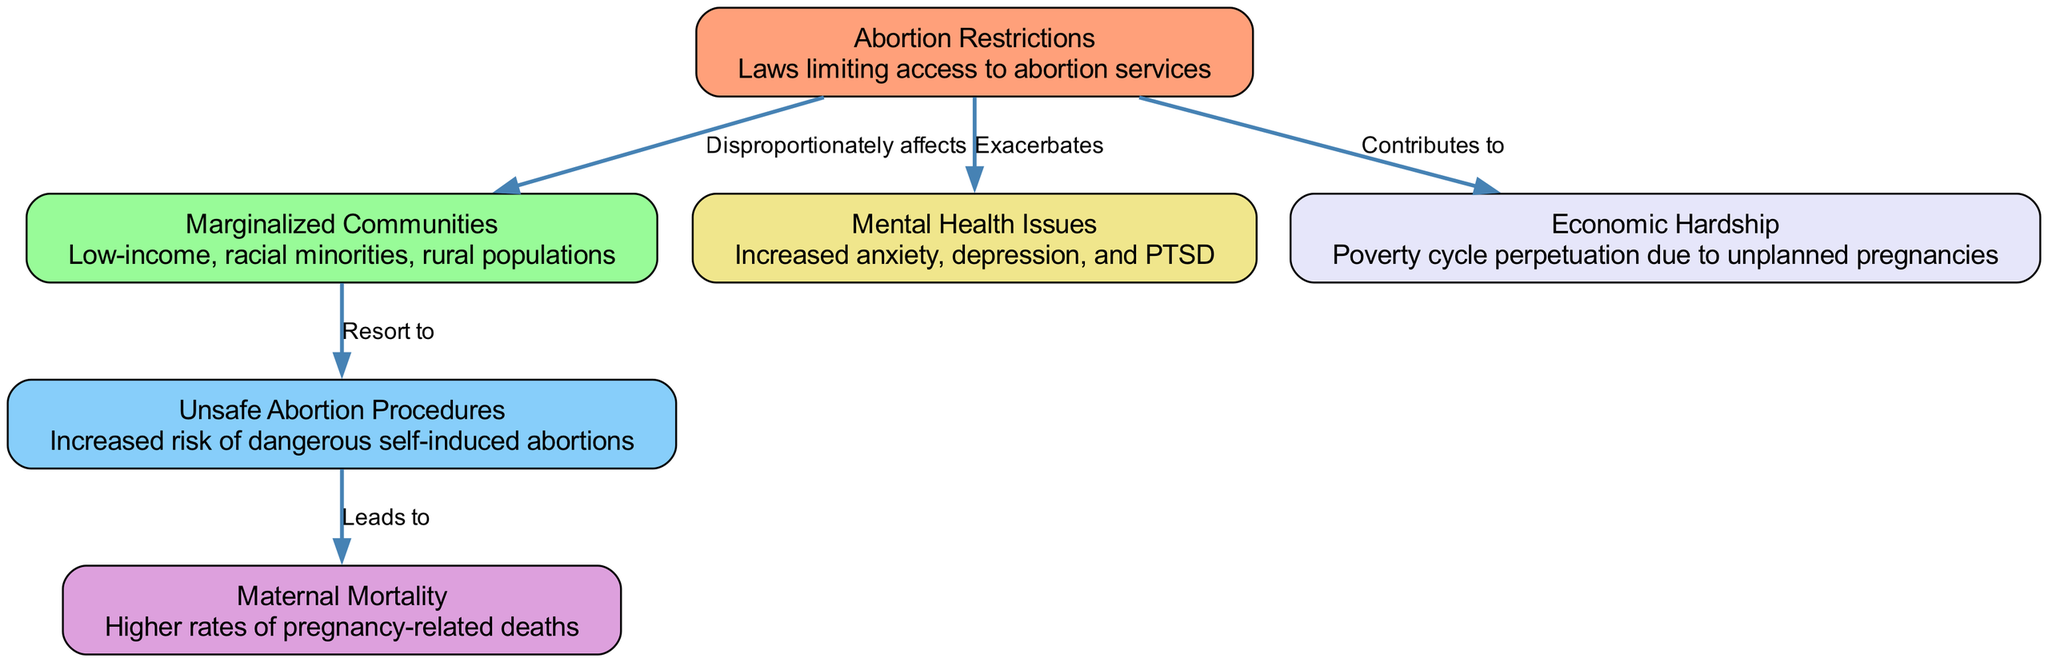What are the two main categories of nodes in the diagram? The diagram has nodes representing "Abortion Restrictions" and "Marginalized Communities." These categories encapsulate the key subjects of the health impacts depicted.
Answer: Abortion Restrictions, Marginalized Communities How many nodes are present in the diagram? By counting each distinct item in the node list, which includes "abortion_restriction," "marginalized_communities," "unsafe_procedures," "maternal_mortality," "mental_health," and "economic_hardship," we find there are six nodes.
Answer: 6 What does "abortion_restriction" disproportionately affect? The diagram indicates that "abortion_restriction" disproportionately affects "marginalized communities," as noted by the directed edge showing this relationship.
Answer: Marginalized Communities What do marginalized communities resort to due to abortion restrictions? The edge from "marginalized_communities" directs us to "unsafe_procedures," indicating their resort to dangerous methods as a consequence of limited access.
Answer: Unsafe Abortion Procedures What is the relationship between unsafe procedures and maternal mortality? The edge demonstrates a direct causation where "unsafe_procedures" leads to "maternal_mortality," illustrating the severe implications of dangerous abortion methods.
Answer: Leads to How does abortion restriction contribute to economic hardship? The directed edge from "abortion_restriction" to "economic_hardship" indicates that restricted access fuels cycles of poverty due to unplanned pregnancies, effectively perpetuating economic difficulties.
Answer: Contributes to What mental health issues are exacerbated by abortion restrictions? The connection from "abortion_restriction" to "mental_health" shows that it exacerbates conditions such as anxiety, depression, and PTSD, highlighting a significant mental health impact.
Answer: Mental Health Issues What is the ultimate effect of unsafe abortion procedures in the diagram? Understanding the flow, we see that "unsafe_procedures" ultimately leads to "maternal_mortality," marking a critical consequence of limited abortion access.
Answer: Maternal Mortality 